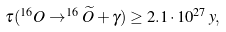Convert formula to latex. <formula><loc_0><loc_0><loc_500><loc_500>\tau ( ^ { 1 6 } O \rightarrow ^ { 1 6 } \widetilde { O } + \gamma ) \geq 2 . 1 \cdot 1 0 ^ { 2 7 } \, y ,</formula> 